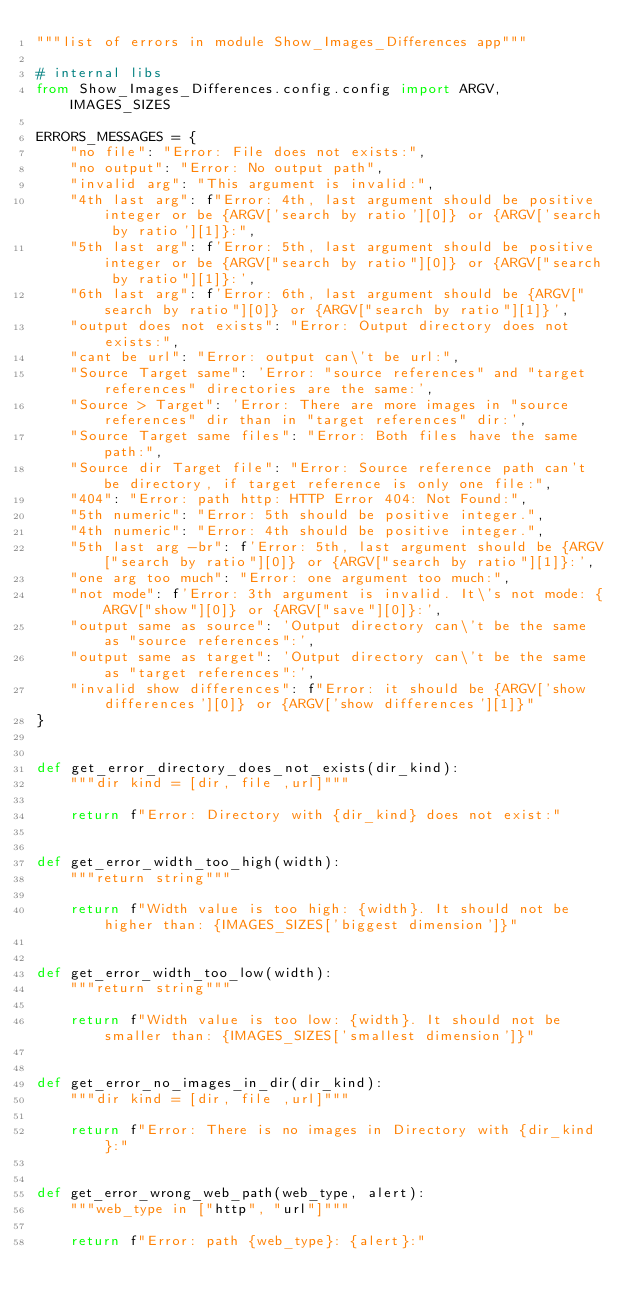Convert code to text. <code><loc_0><loc_0><loc_500><loc_500><_Python_>"""list of errors in module Show_Images_Differences app"""

# internal libs
from Show_Images_Differences.config.config import ARGV, IMAGES_SIZES

ERRORS_MESSAGES = {
    "no file": "Error: File does not exists:",
    "no output": "Error: No output path",
    "invalid arg": "This argument is invalid:",
    "4th last arg": f"Error: 4th, last argument should be positive integer or be {ARGV['search by ratio'][0]} or {ARGV['search by ratio'][1]}:",
    "5th last arg": f'Error: 5th, last argument should be positive integer or be {ARGV["search by ratio"][0]} or {ARGV["search by ratio"][1]}:',
    "6th last arg": f'Error: 6th, last argument should be {ARGV["search by ratio"][0]} or {ARGV["search by ratio"][1]}',
    "output does not exists": "Error: Output directory does not exists:",
    "cant be url": "Error: output can\'t be url:",
    "Source Target same": 'Error: "source references" and "target references" directories are the same:',
    "Source > Target": 'Error: There are more images in "source references" dir than in "target references" dir:',
    "Source Target same files": "Error: Both files have the same path:",
    "Source dir Target file": "Error: Source reference path can't be directory, if target reference is only one file:",
    "404": "Error: path http: HTTP Error 404: Not Found:",
    "5th numeric": "Error: 5th should be positive integer.",
    "4th numeric": "Error: 4th should be positive integer.",
    "5th last arg -br": f'Error: 5th, last argument should be {ARGV["search by ratio"][0]} or {ARGV["search by ratio"][1]}:',
    "one arg too much": "Error: one argument too much:",
    "not mode": f'Error: 3th argument is invalid. It\'s not mode: {ARGV["show"][0]} or {ARGV["save"][0]}:',
    "output same as source": 'Output directory can\'t be the same as "source references":',
    "output same as target": 'Output directory can\'t be the same as "target references":',
    "invalid show differences": f"Error: it should be {ARGV['show differences'][0]} or {ARGV['show differences'][1]}"
}


def get_error_directory_does_not_exists(dir_kind):
    """dir kind = [dir, file ,url]"""

    return f"Error: Directory with {dir_kind} does not exist:"


def get_error_width_too_high(width):
    """return string"""

    return f"Width value is too high: {width}. It should not be higher than: {IMAGES_SIZES['biggest dimension']}"


def get_error_width_too_low(width):
    """return string"""

    return f"Width value is too low: {width}. It should not be smaller than: {IMAGES_SIZES['smallest dimension']}"


def get_error_no_images_in_dir(dir_kind):
    """dir kind = [dir, file ,url]"""

    return f"Error: There is no images in Directory with {dir_kind}:"


def get_error_wrong_web_path(web_type, alert):
    """web_type in ["http", "url"]"""

    return f"Error: path {web_type}: {alert}:"
</code> 